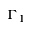Convert formula to latex. <formula><loc_0><loc_0><loc_500><loc_500>\Gamma _ { 1 }</formula> 